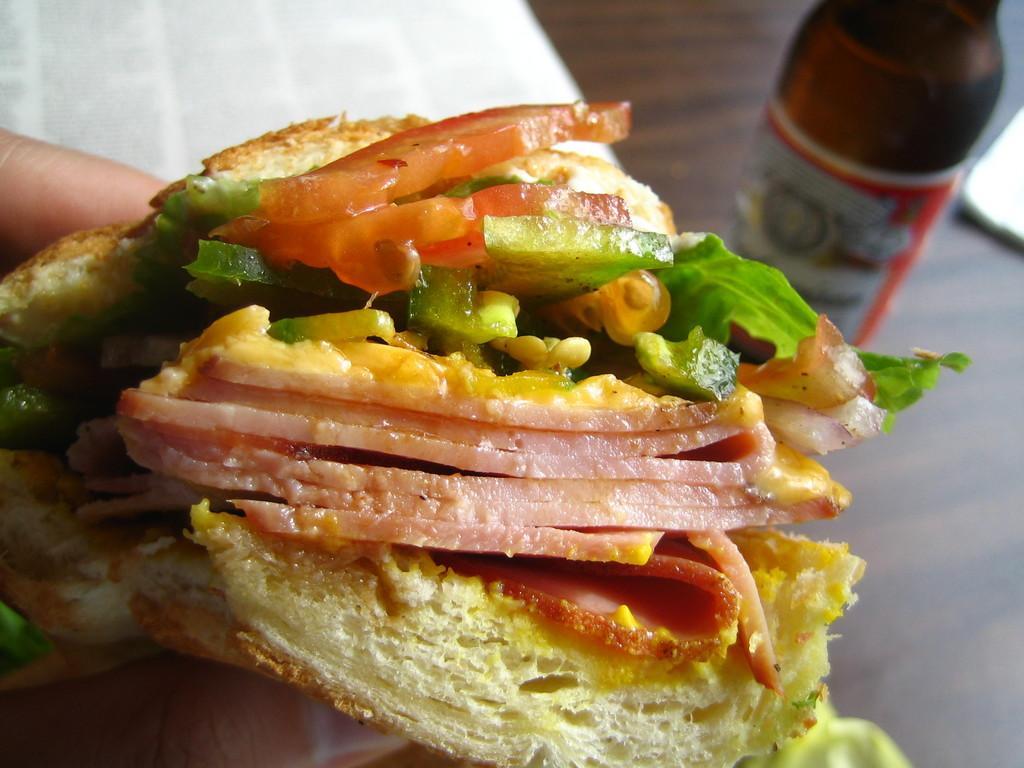How would you summarize this image in a sentence or two? We can see a person's hand holding a sandwich. On that there is meat, green color vegetables, tomato and some other items. In the back there is a table and a bottle with a label on it. 